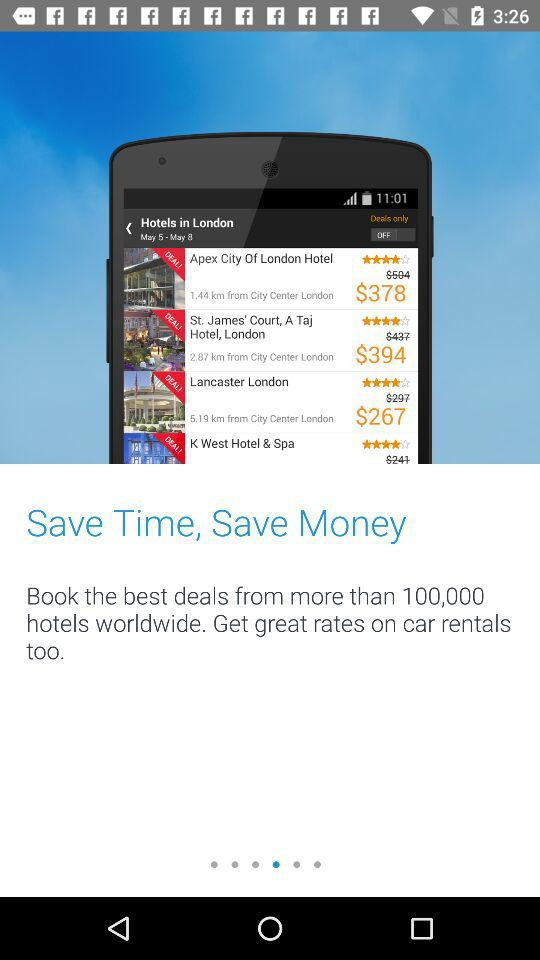What is the rating of Lancaster London? The rating is 4 stars. 